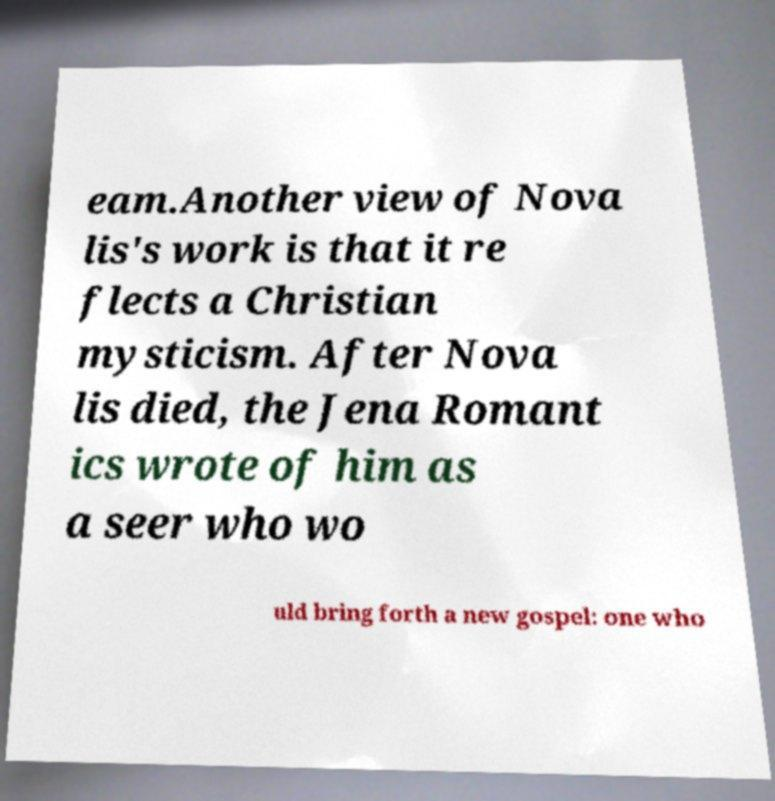For documentation purposes, I need the text within this image transcribed. Could you provide that? eam.Another view of Nova lis's work is that it re flects a Christian mysticism. After Nova lis died, the Jena Romant ics wrote of him as a seer who wo uld bring forth a new gospel: one who 